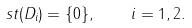Convert formula to latex. <formula><loc_0><loc_0><loc_500><loc_500>\ s t ( D _ { i } ) = \{ 0 \} , \quad i = 1 , 2 .</formula> 